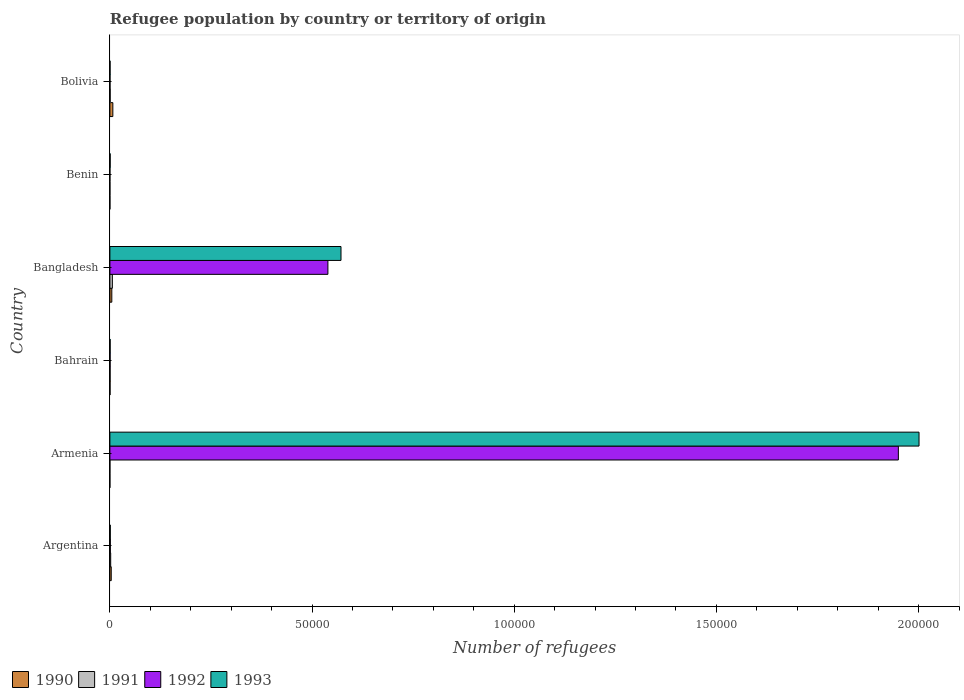How many different coloured bars are there?
Offer a very short reply. 4. Are the number of bars per tick equal to the number of legend labels?
Provide a succinct answer. Yes. How many bars are there on the 1st tick from the bottom?
Make the answer very short. 4. What is the label of the 4th group of bars from the top?
Offer a terse response. Bahrain. Across all countries, what is the maximum number of refugees in 1993?
Your response must be concise. 2.00e+05. In which country was the number of refugees in 1991 maximum?
Give a very brief answer. Bangladesh. In which country was the number of refugees in 1990 minimum?
Offer a terse response. Armenia. What is the total number of refugees in 1992 in the graph?
Your answer should be very brief. 2.49e+05. What is the difference between the number of refugees in 1992 in Bahrain and the number of refugees in 1993 in Bangladesh?
Your answer should be very brief. -5.71e+04. What is the average number of refugees in 1991 per country?
Provide a short and direct response. 155.5. What is the difference between the number of refugees in 1992 and number of refugees in 1990 in Benin?
Ensure brevity in your answer.  2. In how many countries, is the number of refugees in 1993 greater than 80000 ?
Give a very brief answer. 1. What is the ratio of the number of refugees in 1991 in Armenia to that in Bahrain?
Offer a terse response. 0.02. Is the number of refugees in 1992 in Argentina less than that in Bolivia?
Provide a short and direct response. No. Is the difference between the number of refugees in 1992 in Argentina and Bolivia greater than the difference between the number of refugees in 1990 in Argentina and Bolivia?
Provide a succinct answer. Yes. What is the difference between the highest and the second highest number of refugees in 1991?
Keep it short and to the point. 413. What is the difference between the highest and the lowest number of refugees in 1993?
Your answer should be very brief. 2.00e+05. In how many countries, is the number of refugees in 1991 greater than the average number of refugees in 1991 taken over all countries?
Keep it short and to the point. 2. Is the sum of the number of refugees in 1992 in Bahrain and Benin greater than the maximum number of refugees in 1993 across all countries?
Keep it short and to the point. No. What does the 1st bar from the bottom in Bahrain represents?
Provide a succinct answer. 1990. Is it the case that in every country, the sum of the number of refugees in 1990 and number of refugees in 1993 is greater than the number of refugees in 1992?
Your answer should be very brief. Yes. How many bars are there?
Keep it short and to the point. 24. Are all the bars in the graph horizontal?
Make the answer very short. Yes. Where does the legend appear in the graph?
Provide a short and direct response. Bottom left. What is the title of the graph?
Your answer should be compact. Refugee population by country or territory of origin. What is the label or title of the X-axis?
Give a very brief answer. Number of refugees. What is the Number of refugees in 1990 in Argentina?
Your response must be concise. 334. What is the Number of refugees in 1991 in Argentina?
Make the answer very short. 198. What is the Number of refugees in 1992 in Argentina?
Your answer should be very brief. 113. What is the Number of refugees in 1991 in Armenia?
Your answer should be compact. 1. What is the Number of refugees of 1992 in Armenia?
Make the answer very short. 1.95e+05. What is the Number of refugees of 1993 in Armenia?
Provide a succinct answer. 2.00e+05. What is the Number of refugees in 1990 in Bangladesh?
Your answer should be very brief. 477. What is the Number of refugees of 1991 in Bangladesh?
Provide a succinct answer. 611. What is the Number of refugees in 1992 in Bangladesh?
Provide a short and direct response. 5.39e+04. What is the Number of refugees of 1993 in Bangladesh?
Give a very brief answer. 5.72e+04. What is the Number of refugees of 1990 in Bolivia?
Give a very brief answer. 731. What is the Number of refugees of 1991 in Bolivia?
Offer a very short reply. 67. What is the Number of refugees in 1993 in Bolivia?
Ensure brevity in your answer.  41. Across all countries, what is the maximum Number of refugees of 1990?
Make the answer very short. 731. Across all countries, what is the maximum Number of refugees of 1991?
Offer a very short reply. 611. Across all countries, what is the maximum Number of refugees in 1992?
Your answer should be very brief. 1.95e+05. Across all countries, what is the maximum Number of refugees in 1993?
Give a very brief answer. 2.00e+05. Across all countries, what is the minimum Number of refugees of 1990?
Keep it short and to the point. 1. Across all countries, what is the minimum Number of refugees in 1991?
Keep it short and to the point. 1. Across all countries, what is the minimum Number of refugees of 1992?
Ensure brevity in your answer.  4. Across all countries, what is the minimum Number of refugees in 1993?
Give a very brief answer. 41. What is the total Number of refugees of 1990 in the graph?
Your answer should be very brief. 1584. What is the total Number of refugees of 1991 in the graph?
Offer a very short reply. 933. What is the total Number of refugees in 1992 in the graph?
Your answer should be very brief. 2.49e+05. What is the total Number of refugees in 1993 in the graph?
Make the answer very short. 2.58e+05. What is the difference between the Number of refugees of 1990 in Argentina and that in Armenia?
Your answer should be very brief. 333. What is the difference between the Number of refugees in 1991 in Argentina and that in Armenia?
Give a very brief answer. 197. What is the difference between the Number of refugees in 1992 in Argentina and that in Armenia?
Your answer should be compact. -1.95e+05. What is the difference between the Number of refugees of 1993 in Argentina and that in Armenia?
Make the answer very short. -2.00e+05. What is the difference between the Number of refugees in 1990 in Argentina and that in Bahrain?
Your response must be concise. 295. What is the difference between the Number of refugees in 1991 in Argentina and that in Bahrain?
Give a very brief answer. 146. What is the difference between the Number of refugees of 1992 in Argentina and that in Bahrain?
Your response must be concise. 60. What is the difference between the Number of refugees in 1990 in Argentina and that in Bangladesh?
Your answer should be compact. -143. What is the difference between the Number of refugees in 1991 in Argentina and that in Bangladesh?
Keep it short and to the point. -413. What is the difference between the Number of refugees of 1992 in Argentina and that in Bangladesh?
Your answer should be very brief. -5.38e+04. What is the difference between the Number of refugees of 1993 in Argentina and that in Bangladesh?
Make the answer very short. -5.71e+04. What is the difference between the Number of refugees in 1990 in Argentina and that in Benin?
Give a very brief answer. 332. What is the difference between the Number of refugees in 1991 in Argentina and that in Benin?
Make the answer very short. 194. What is the difference between the Number of refugees of 1992 in Argentina and that in Benin?
Keep it short and to the point. 109. What is the difference between the Number of refugees of 1993 in Argentina and that in Benin?
Provide a short and direct response. 30. What is the difference between the Number of refugees of 1990 in Argentina and that in Bolivia?
Keep it short and to the point. -397. What is the difference between the Number of refugees in 1991 in Argentina and that in Bolivia?
Offer a terse response. 131. What is the difference between the Number of refugees in 1993 in Argentina and that in Bolivia?
Ensure brevity in your answer.  57. What is the difference between the Number of refugees of 1990 in Armenia and that in Bahrain?
Offer a terse response. -38. What is the difference between the Number of refugees in 1991 in Armenia and that in Bahrain?
Give a very brief answer. -51. What is the difference between the Number of refugees in 1992 in Armenia and that in Bahrain?
Provide a short and direct response. 1.95e+05. What is the difference between the Number of refugees in 1993 in Armenia and that in Bahrain?
Give a very brief answer. 2.00e+05. What is the difference between the Number of refugees of 1990 in Armenia and that in Bangladesh?
Keep it short and to the point. -476. What is the difference between the Number of refugees of 1991 in Armenia and that in Bangladesh?
Give a very brief answer. -610. What is the difference between the Number of refugees of 1992 in Armenia and that in Bangladesh?
Your answer should be very brief. 1.41e+05. What is the difference between the Number of refugees of 1993 in Armenia and that in Bangladesh?
Offer a very short reply. 1.43e+05. What is the difference between the Number of refugees of 1992 in Armenia and that in Benin?
Make the answer very short. 1.95e+05. What is the difference between the Number of refugees in 1993 in Armenia and that in Benin?
Give a very brief answer. 2.00e+05. What is the difference between the Number of refugees in 1990 in Armenia and that in Bolivia?
Your answer should be very brief. -730. What is the difference between the Number of refugees in 1991 in Armenia and that in Bolivia?
Your response must be concise. -66. What is the difference between the Number of refugees of 1992 in Armenia and that in Bolivia?
Your answer should be very brief. 1.95e+05. What is the difference between the Number of refugees of 1993 in Armenia and that in Bolivia?
Ensure brevity in your answer.  2.00e+05. What is the difference between the Number of refugees of 1990 in Bahrain and that in Bangladesh?
Provide a succinct answer. -438. What is the difference between the Number of refugees in 1991 in Bahrain and that in Bangladesh?
Offer a very short reply. -559. What is the difference between the Number of refugees of 1992 in Bahrain and that in Bangladesh?
Provide a succinct answer. -5.39e+04. What is the difference between the Number of refugees in 1993 in Bahrain and that in Bangladesh?
Offer a very short reply. -5.71e+04. What is the difference between the Number of refugees in 1990 in Bahrain and that in Benin?
Your answer should be compact. 37. What is the difference between the Number of refugees in 1992 in Bahrain and that in Benin?
Make the answer very short. 49. What is the difference between the Number of refugees in 1990 in Bahrain and that in Bolivia?
Your response must be concise. -692. What is the difference between the Number of refugees of 1992 in Bahrain and that in Bolivia?
Your response must be concise. 25. What is the difference between the Number of refugees in 1990 in Bangladesh and that in Benin?
Your response must be concise. 475. What is the difference between the Number of refugees of 1991 in Bangladesh and that in Benin?
Offer a terse response. 607. What is the difference between the Number of refugees of 1992 in Bangladesh and that in Benin?
Ensure brevity in your answer.  5.39e+04. What is the difference between the Number of refugees of 1993 in Bangladesh and that in Benin?
Give a very brief answer. 5.71e+04. What is the difference between the Number of refugees in 1990 in Bangladesh and that in Bolivia?
Your response must be concise. -254. What is the difference between the Number of refugees in 1991 in Bangladesh and that in Bolivia?
Make the answer very short. 544. What is the difference between the Number of refugees in 1992 in Bangladesh and that in Bolivia?
Keep it short and to the point. 5.39e+04. What is the difference between the Number of refugees of 1993 in Bangladesh and that in Bolivia?
Offer a very short reply. 5.71e+04. What is the difference between the Number of refugees of 1990 in Benin and that in Bolivia?
Keep it short and to the point. -729. What is the difference between the Number of refugees in 1991 in Benin and that in Bolivia?
Make the answer very short. -63. What is the difference between the Number of refugees in 1990 in Argentina and the Number of refugees in 1991 in Armenia?
Ensure brevity in your answer.  333. What is the difference between the Number of refugees of 1990 in Argentina and the Number of refugees of 1992 in Armenia?
Make the answer very short. -1.95e+05. What is the difference between the Number of refugees of 1990 in Argentina and the Number of refugees of 1993 in Armenia?
Give a very brief answer. -2.00e+05. What is the difference between the Number of refugees of 1991 in Argentina and the Number of refugees of 1992 in Armenia?
Ensure brevity in your answer.  -1.95e+05. What is the difference between the Number of refugees in 1991 in Argentina and the Number of refugees in 1993 in Armenia?
Your response must be concise. -2.00e+05. What is the difference between the Number of refugees in 1992 in Argentina and the Number of refugees in 1993 in Armenia?
Your answer should be very brief. -2.00e+05. What is the difference between the Number of refugees of 1990 in Argentina and the Number of refugees of 1991 in Bahrain?
Your answer should be compact. 282. What is the difference between the Number of refugees of 1990 in Argentina and the Number of refugees of 1992 in Bahrain?
Provide a succinct answer. 281. What is the difference between the Number of refugees of 1990 in Argentina and the Number of refugees of 1993 in Bahrain?
Make the answer very short. 274. What is the difference between the Number of refugees of 1991 in Argentina and the Number of refugees of 1992 in Bahrain?
Offer a terse response. 145. What is the difference between the Number of refugees in 1991 in Argentina and the Number of refugees in 1993 in Bahrain?
Offer a very short reply. 138. What is the difference between the Number of refugees of 1992 in Argentina and the Number of refugees of 1993 in Bahrain?
Offer a very short reply. 53. What is the difference between the Number of refugees in 1990 in Argentina and the Number of refugees in 1991 in Bangladesh?
Ensure brevity in your answer.  -277. What is the difference between the Number of refugees in 1990 in Argentina and the Number of refugees in 1992 in Bangladesh?
Offer a terse response. -5.36e+04. What is the difference between the Number of refugees of 1990 in Argentina and the Number of refugees of 1993 in Bangladesh?
Ensure brevity in your answer.  -5.68e+04. What is the difference between the Number of refugees of 1991 in Argentina and the Number of refugees of 1992 in Bangladesh?
Your answer should be very brief. -5.37e+04. What is the difference between the Number of refugees in 1991 in Argentina and the Number of refugees in 1993 in Bangladesh?
Provide a short and direct response. -5.70e+04. What is the difference between the Number of refugees in 1992 in Argentina and the Number of refugees in 1993 in Bangladesh?
Offer a terse response. -5.70e+04. What is the difference between the Number of refugees in 1990 in Argentina and the Number of refugees in 1991 in Benin?
Offer a very short reply. 330. What is the difference between the Number of refugees of 1990 in Argentina and the Number of refugees of 1992 in Benin?
Ensure brevity in your answer.  330. What is the difference between the Number of refugees of 1990 in Argentina and the Number of refugees of 1993 in Benin?
Offer a terse response. 266. What is the difference between the Number of refugees in 1991 in Argentina and the Number of refugees in 1992 in Benin?
Offer a very short reply. 194. What is the difference between the Number of refugees in 1991 in Argentina and the Number of refugees in 1993 in Benin?
Your answer should be compact. 130. What is the difference between the Number of refugees of 1990 in Argentina and the Number of refugees of 1991 in Bolivia?
Offer a terse response. 267. What is the difference between the Number of refugees of 1990 in Argentina and the Number of refugees of 1992 in Bolivia?
Your answer should be compact. 306. What is the difference between the Number of refugees of 1990 in Argentina and the Number of refugees of 1993 in Bolivia?
Give a very brief answer. 293. What is the difference between the Number of refugees in 1991 in Argentina and the Number of refugees in 1992 in Bolivia?
Your answer should be compact. 170. What is the difference between the Number of refugees in 1991 in Argentina and the Number of refugees in 1993 in Bolivia?
Keep it short and to the point. 157. What is the difference between the Number of refugees in 1990 in Armenia and the Number of refugees in 1991 in Bahrain?
Ensure brevity in your answer.  -51. What is the difference between the Number of refugees in 1990 in Armenia and the Number of refugees in 1992 in Bahrain?
Ensure brevity in your answer.  -52. What is the difference between the Number of refugees in 1990 in Armenia and the Number of refugees in 1993 in Bahrain?
Give a very brief answer. -59. What is the difference between the Number of refugees in 1991 in Armenia and the Number of refugees in 1992 in Bahrain?
Make the answer very short. -52. What is the difference between the Number of refugees in 1991 in Armenia and the Number of refugees in 1993 in Bahrain?
Provide a succinct answer. -59. What is the difference between the Number of refugees of 1992 in Armenia and the Number of refugees of 1993 in Bahrain?
Offer a terse response. 1.95e+05. What is the difference between the Number of refugees in 1990 in Armenia and the Number of refugees in 1991 in Bangladesh?
Your answer should be very brief. -610. What is the difference between the Number of refugees in 1990 in Armenia and the Number of refugees in 1992 in Bangladesh?
Your response must be concise. -5.39e+04. What is the difference between the Number of refugees in 1990 in Armenia and the Number of refugees in 1993 in Bangladesh?
Offer a very short reply. -5.72e+04. What is the difference between the Number of refugees of 1991 in Armenia and the Number of refugees of 1992 in Bangladesh?
Offer a very short reply. -5.39e+04. What is the difference between the Number of refugees in 1991 in Armenia and the Number of refugees in 1993 in Bangladesh?
Ensure brevity in your answer.  -5.72e+04. What is the difference between the Number of refugees of 1992 in Armenia and the Number of refugees of 1993 in Bangladesh?
Your answer should be compact. 1.38e+05. What is the difference between the Number of refugees of 1990 in Armenia and the Number of refugees of 1991 in Benin?
Provide a short and direct response. -3. What is the difference between the Number of refugees of 1990 in Armenia and the Number of refugees of 1992 in Benin?
Keep it short and to the point. -3. What is the difference between the Number of refugees of 1990 in Armenia and the Number of refugees of 1993 in Benin?
Make the answer very short. -67. What is the difference between the Number of refugees in 1991 in Armenia and the Number of refugees in 1992 in Benin?
Make the answer very short. -3. What is the difference between the Number of refugees in 1991 in Armenia and the Number of refugees in 1993 in Benin?
Give a very brief answer. -67. What is the difference between the Number of refugees of 1992 in Armenia and the Number of refugees of 1993 in Benin?
Ensure brevity in your answer.  1.95e+05. What is the difference between the Number of refugees in 1990 in Armenia and the Number of refugees in 1991 in Bolivia?
Offer a very short reply. -66. What is the difference between the Number of refugees of 1990 in Armenia and the Number of refugees of 1993 in Bolivia?
Make the answer very short. -40. What is the difference between the Number of refugees of 1991 in Armenia and the Number of refugees of 1992 in Bolivia?
Provide a short and direct response. -27. What is the difference between the Number of refugees in 1992 in Armenia and the Number of refugees in 1993 in Bolivia?
Provide a short and direct response. 1.95e+05. What is the difference between the Number of refugees in 1990 in Bahrain and the Number of refugees in 1991 in Bangladesh?
Make the answer very short. -572. What is the difference between the Number of refugees of 1990 in Bahrain and the Number of refugees of 1992 in Bangladesh?
Your response must be concise. -5.39e+04. What is the difference between the Number of refugees in 1990 in Bahrain and the Number of refugees in 1993 in Bangladesh?
Give a very brief answer. -5.71e+04. What is the difference between the Number of refugees of 1991 in Bahrain and the Number of refugees of 1992 in Bangladesh?
Give a very brief answer. -5.39e+04. What is the difference between the Number of refugees of 1991 in Bahrain and the Number of refugees of 1993 in Bangladesh?
Provide a short and direct response. -5.71e+04. What is the difference between the Number of refugees in 1992 in Bahrain and the Number of refugees in 1993 in Bangladesh?
Make the answer very short. -5.71e+04. What is the difference between the Number of refugees in 1990 in Bahrain and the Number of refugees in 1991 in Benin?
Your answer should be compact. 35. What is the difference between the Number of refugees of 1990 in Bahrain and the Number of refugees of 1993 in Benin?
Offer a terse response. -29. What is the difference between the Number of refugees in 1991 in Bahrain and the Number of refugees in 1993 in Benin?
Keep it short and to the point. -16. What is the difference between the Number of refugees of 1991 in Bahrain and the Number of refugees of 1993 in Bolivia?
Your answer should be very brief. 11. What is the difference between the Number of refugees of 1992 in Bahrain and the Number of refugees of 1993 in Bolivia?
Give a very brief answer. 12. What is the difference between the Number of refugees in 1990 in Bangladesh and the Number of refugees in 1991 in Benin?
Give a very brief answer. 473. What is the difference between the Number of refugees of 1990 in Bangladesh and the Number of refugees of 1992 in Benin?
Give a very brief answer. 473. What is the difference between the Number of refugees in 1990 in Bangladesh and the Number of refugees in 1993 in Benin?
Ensure brevity in your answer.  409. What is the difference between the Number of refugees in 1991 in Bangladesh and the Number of refugees in 1992 in Benin?
Offer a terse response. 607. What is the difference between the Number of refugees of 1991 in Bangladesh and the Number of refugees of 1993 in Benin?
Make the answer very short. 543. What is the difference between the Number of refugees in 1992 in Bangladesh and the Number of refugees in 1993 in Benin?
Keep it short and to the point. 5.39e+04. What is the difference between the Number of refugees of 1990 in Bangladesh and the Number of refugees of 1991 in Bolivia?
Ensure brevity in your answer.  410. What is the difference between the Number of refugees in 1990 in Bangladesh and the Number of refugees in 1992 in Bolivia?
Your answer should be compact. 449. What is the difference between the Number of refugees of 1990 in Bangladesh and the Number of refugees of 1993 in Bolivia?
Make the answer very short. 436. What is the difference between the Number of refugees of 1991 in Bangladesh and the Number of refugees of 1992 in Bolivia?
Provide a succinct answer. 583. What is the difference between the Number of refugees of 1991 in Bangladesh and the Number of refugees of 1993 in Bolivia?
Offer a terse response. 570. What is the difference between the Number of refugees of 1992 in Bangladesh and the Number of refugees of 1993 in Bolivia?
Keep it short and to the point. 5.39e+04. What is the difference between the Number of refugees in 1990 in Benin and the Number of refugees in 1991 in Bolivia?
Ensure brevity in your answer.  -65. What is the difference between the Number of refugees in 1990 in Benin and the Number of refugees in 1993 in Bolivia?
Your answer should be compact. -39. What is the difference between the Number of refugees of 1991 in Benin and the Number of refugees of 1993 in Bolivia?
Provide a short and direct response. -37. What is the difference between the Number of refugees of 1992 in Benin and the Number of refugees of 1993 in Bolivia?
Your answer should be very brief. -37. What is the average Number of refugees in 1990 per country?
Your answer should be very brief. 264. What is the average Number of refugees in 1991 per country?
Offer a terse response. 155.5. What is the average Number of refugees of 1992 per country?
Provide a succinct answer. 4.15e+04. What is the average Number of refugees in 1993 per country?
Your answer should be very brief. 4.29e+04. What is the difference between the Number of refugees in 1990 and Number of refugees in 1991 in Argentina?
Provide a succinct answer. 136. What is the difference between the Number of refugees of 1990 and Number of refugees of 1992 in Argentina?
Make the answer very short. 221. What is the difference between the Number of refugees of 1990 and Number of refugees of 1993 in Argentina?
Give a very brief answer. 236. What is the difference between the Number of refugees in 1991 and Number of refugees in 1993 in Argentina?
Ensure brevity in your answer.  100. What is the difference between the Number of refugees in 1990 and Number of refugees in 1991 in Armenia?
Keep it short and to the point. 0. What is the difference between the Number of refugees in 1990 and Number of refugees in 1992 in Armenia?
Your answer should be very brief. -1.95e+05. What is the difference between the Number of refugees in 1990 and Number of refugees in 1993 in Armenia?
Provide a short and direct response. -2.00e+05. What is the difference between the Number of refugees of 1991 and Number of refugees of 1992 in Armenia?
Ensure brevity in your answer.  -1.95e+05. What is the difference between the Number of refugees in 1991 and Number of refugees in 1993 in Armenia?
Your answer should be compact. -2.00e+05. What is the difference between the Number of refugees in 1992 and Number of refugees in 1993 in Armenia?
Offer a very short reply. -5113. What is the difference between the Number of refugees of 1990 and Number of refugees of 1992 in Bahrain?
Provide a succinct answer. -14. What is the difference between the Number of refugees of 1991 and Number of refugees of 1992 in Bahrain?
Your answer should be very brief. -1. What is the difference between the Number of refugees in 1991 and Number of refugees in 1993 in Bahrain?
Offer a terse response. -8. What is the difference between the Number of refugees of 1990 and Number of refugees of 1991 in Bangladesh?
Provide a short and direct response. -134. What is the difference between the Number of refugees in 1990 and Number of refugees in 1992 in Bangladesh?
Your response must be concise. -5.34e+04. What is the difference between the Number of refugees in 1990 and Number of refugees in 1993 in Bangladesh?
Your answer should be very brief. -5.67e+04. What is the difference between the Number of refugees of 1991 and Number of refugees of 1992 in Bangladesh?
Keep it short and to the point. -5.33e+04. What is the difference between the Number of refugees in 1991 and Number of refugees in 1993 in Bangladesh?
Provide a succinct answer. -5.65e+04. What is the difference between the Number of refugees in 1992 and Number of refugees in 1993 in Bangladesh?
Ensure brevity in your answer.  -3237. What is the difference between the Number of refugees in 1990 and Number of refugees in 1993 in Benin?
Ensure brevity in your answer.  -66. What is the difference between the Number of refugees of 1991 and Number of refugees of 1993 in Benin?
Offer a very short reply. -64. What is the difference between the Number of refugees in 1992 and Number of refugees in 1993 in Benin?
Keep it short and to the point. -64. What is the difference between the Number of refugees in 1990 and Number of refugees in 1991 in Bolivia?
Offer a very short reply. 664. What is the difference between the Number of refugees of 1990 and Number of refugees of 1992 in Bolivia?
Offer a very short reply. 703. What is the difference between the Number of refugees in 1990 and Number of refugees in 1993 in Bolivia?
Keep it short and to the point. 690. What is the difference between the Number of refugees in 1991 and Number of refugees in 1992 in Bolivia?
Your answer should be very brief. 39. What is the ratio of the Number of refugees of 1990 in Argentina to that in Armenia?
Ensure brevity in your answer.  334. What is the ratio of the Number of refugees in 1991 in Argentina to that in Armenia?
Ensure brevity in your answer.  198. What is the ratio of the Number of refugees in 1992 in Argentina to that in Armenia?
Offer a terse response. 0. What is the ratio of the Number of refugees of 1990 in Argentina to that in Bahrain?
Your answer should be compact. 8.56. What is the ratio of the Number of refugees of 1991 in Argentina to that in Bahrain?
Give a very brief answer. 3.81. What is the ratio of the Number of refugees of 1992 in Argentina to that in Bahrain?
Keep it short and to the point. 2.13. What is the ratio of the Number of refugees of 1993 in Argentina to that in Bahrain?
Provide a short and direct response. 1.63. What is the ratio of the Number of refugees in 1990 in Argentina to that in Bangladesh?
Give a very brief answer. 0.7. What is the ratio of the Number of refugees in 1991 in Argentina to that in Bangladesh?
Your answer should be compact. 0.32. What is the ratio of the Number of refugees in 1992 in Argentina to that in Bangladesh?
Keep it short and to the point. 0. What is the ratio of the Number of refugees in 1993 in Argentina to that in Bangladesh?
Ensure brevity in your answer.  0. What is the ratio of the Number of refugees in 1990 in Argentina to that in Benin?
Make the answer very short. 167. What is the ratio of the Number of refugees of 1991 in Argentina to that in Benin?
Make the answer very short. 49.5. What is the ratio of the Number of refugees in 1992 in Argentina to that in Benin?
Ensure brevity in your answer.  28.25. What is the ratio of the Number of refugees of 1993 in Argentina to that in Benin?
Your response must be concise. 1.44. What is the ratio of the Number of refugees in 1990 in Argentina to that in Bolivia?
Give a very brief answer. 0.46. What is the ratio of the Number of refugees in 1991 in Argentina to that in Bolivia?
Provide a short and direct response. 2.96. What is the ratio of the Number of refugees of 1992 in Argentina to that in Bolivia?
Your answer should be very brief. 4.04. What is the ratio of the Number of refugees of 1993 in Argentina to that in Bolivia?
Your answer should be compact. 2.39. What is the ratio of the Number of refugees in 1990 in Armenia to that in Bahrain?
Provide a succinct answer. 0.03. What is the ratio of the Number of refugees of 1991 in Armenia to that in Bahrain?
Provide a short and direct response. 0.02. What is the ratio of the Number of refugees of 1992 in Armenia to that in Bahrain?
Offer a very short reply. 3679.3. What is the ratio of the Number of refugees of 1993 in Armenia to that in Bahrain?
Make the answer very short. 3335.27. What is the ratio of the Number of refugees in 1990 in Armenia to that in Bangladesh?
Keep it short and to the point. 0. What is the ratio of the Number of refugees of 1991 in Armenia to that in Bangladesh?
Offer a very short reply. 0. What is the ratio of the Number of refugees in 1992 in Armenia to that in Bangladesh?
Offer a very short reply. 3.62. What is the ratio of the Number of refugees of 1993 in Armenia to that in Bangladesh?
Offer a terse response. 3.5. What is the ratio of the Number of refugees of 1992 in Armenia to that in Benin?
Your answer should be compact. 4.88e+04. What is the ratio of the Number of refugees in 1993 in Armenia to that in Benin?
Keep it short and to the point. 2942.88. What is the ratio of the Number of refugees of 1990 in Armenia to that in Bolivia?
Make the answer very short. 0. What is the ratio of the Number of refugees in 1991 in Armenia to that in Bolivia?
Provide a succinct answer. 0.01. What is the ratio of the Number of refugees in 1992 in Armenia to that in Bolivia?
Offer a very short reply. 6964.39. What is the ratio of the Number of refugees of 1993 in Armenia to that in Bolivia?
Your response must be concise. 4880.88. What is the ratio of the Number of refugees of 1990 in Bahrain to that in Bangladesh?
Your response must be concise. 0.08. What is the ratio of the Number of refugees in 1991 in Bahrain to that in Bangladesh?
Your response must be concise. 0.09. What is the ratio of the Number of refugees in 1992 in Bahrain to that in Benin?
Offer a terse response. 13.25. What is the ratio of the Number of refugees in 1993 in Bahrain to that in Benin?
Keep it short and to the point. 0.88. What is the ratio of the Number of refugees of 1990 in Bahrain to that in Bolivia?
Offer a very short reply. 0.05. What is the ratio of the Number of refugees in 1991 in Bahrain to that in Bolivia?
Your answer should be compact. 0.78. What is the ratio of the Number of refugees of 1992 in Bahrain to that in Bolivia?
Ensure brevity in your answer.  1.89. What is the ratio of the Number of refugees in 1993 in Bahrain to that in Bolivia?
Your answer should be very brief. 1.46. What is the ratio of the Number of refugees in 1990 in Bangladesh to that in Benin?
Give a very brief answer. 238.5. What is the ratio of the Number of refugees in 1991 in Bangladesh to that in Benin?
Your answer should be compact. 152.75. What is the ratio of the Number of refugees in 1992 in Bangladesh to that in Benin?
Offer a very short reply. 1.35e+04. What is the ratio of the Number of refugees in 1993 in Bangladesh to that in Benin?
Your answer should be compact. 840.56. What is the ratio of the Number of refugees of 1990 in Bangladesh to that in Bolivia?
Your answer should be very brief. 0.65. What is the ratio of the Number of refugees of 1991 in Bangladesh to that in Bolivia?
Give a very brief answer. 9.12. What is the ratio of the Number of refugees in 1992 in Bangladesh to that in Bolivia?
Your answer should be very brief. 1925.75. What is the ratio of the Number of refugees of 1993 in Bangladesh to that in Bolivia?
Keep it short and to the point. 1394.1. What is the ratio of the Number of refugees of 1990 in Benin to that in Bolivia?
Provide a succinct answer. 0. What is the ratio of the Number of refugees of 1991 in Benin to that in Bolivia?
Provide a short and direct response. 0.06. What is the ratio of the Number of refugees in 1992 in Benin to that in Bolivia?
Give a very brief answer. 0.14. What is the ratio of the Number of refugees in 1993 in Benin to that in Bolivia?
Make the answer very short. 1.66. What is the difference between the highest and the second highest Number of refugees in 1990?
Keep it short and to the point. 254. What is the difference between the highest and the second highest Number of refugees of 1991?
Offer a very short reply. 413. What is the difference between the highest and the second highest Number of refugees in 1992?
Your response must be concise. 1.41e+05. What is the difference between the highest and the second highest Number of refugees of 1993?
Your response must be concise. 1.43e+05. What is the difference between the highest and the lowest Number of refugees of 1990?
Provide a succinct answer. 730. What is the difference between the highest and the lowest Number of refugees of 1991?
Provide a short and direct response. 610. What is the difference between the highest and the lowest Number of refugees of 1992?
Offer a terse response. 1.95e+05. What is the difference between the highest and the lowest Number of refugees of 1993?
Provide a succinct answer. 2.00e+05. 